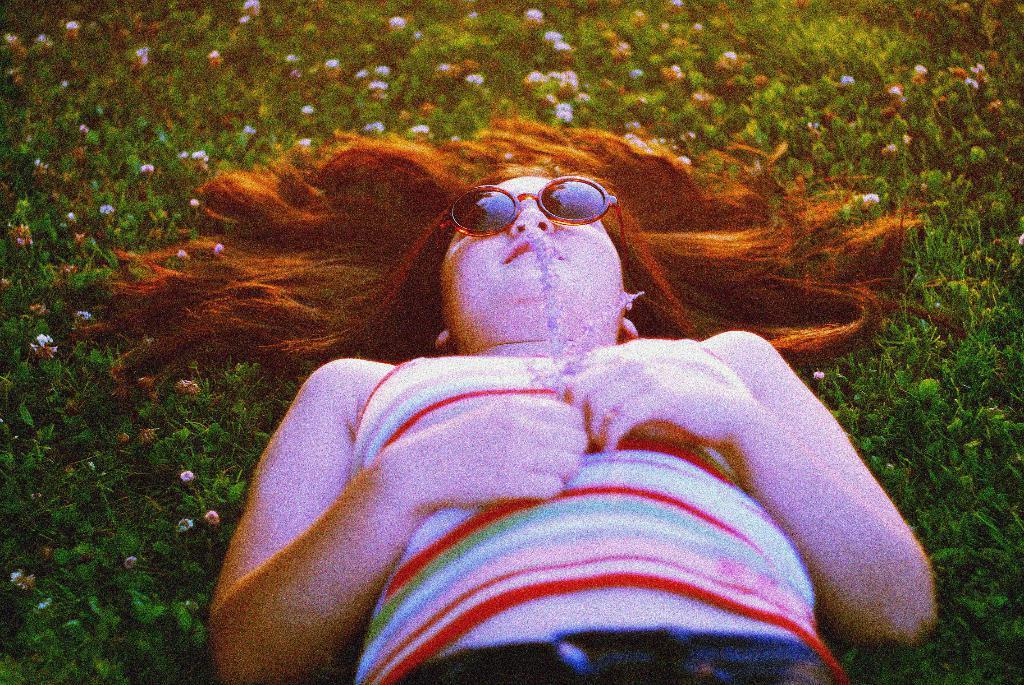Who is the main subject in the image? There is a girl in the image. What is the girl doing in the image? The girl is lying on the ground. What can be seen in the background of the image? There is grass and flowers in the background of the image. Is there a stove visible in the image? No, there is no stove present in the image. 